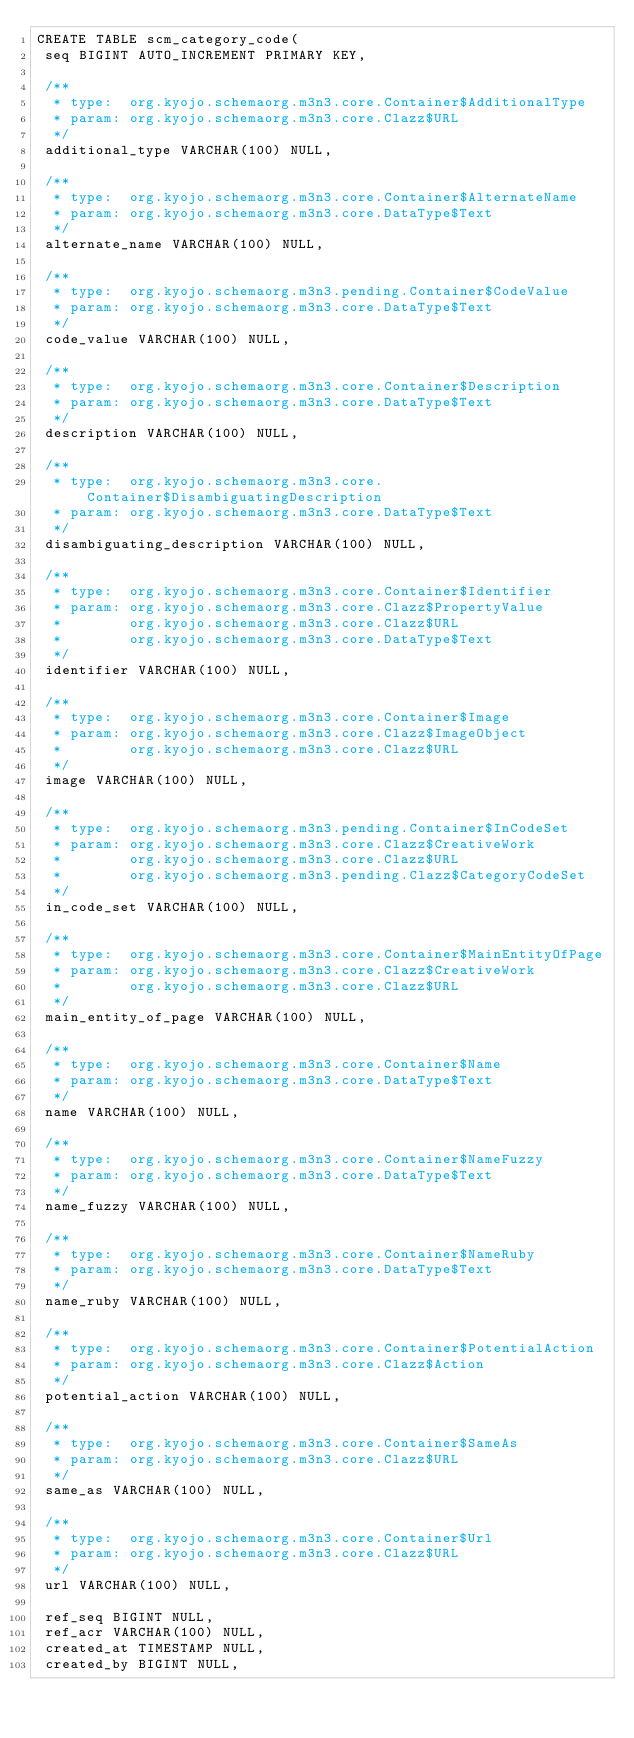<code> <loc_0><loc_0><loc_500><loc_500><_SQL_>CREATE TABLE scm_category_code(
 seq BIGINT AUTO_INCREMENT PRIMARY KEY,

 /**
  * type:  org.kyojo.schemaorg.m3n3.core.Container$AdditionalType
  * param: org.kyojo.schemaorg.m3n3.core.Clazz$URL
  */
 additional_type VARCHAR(100) NULL,

 /**
  * type:  org.kyojo.schemaorg.m3n3.core.Container$AlternateName
  * param: org.kyojo.schemaorg.m3n3.core.DataType$Text
  */
 alternate_name VARCHAR(100) NULL,

 /**
  * type:  org.kyojo.schemaorg.m3n3.pending.Container$CodeValue
  * param: org.kyojo.schemaorg.m3n3.core.DataType$Text
  */
 code_value VARCHAR(100) NULL,

 /**
  * type:  org.kyojo.schemaorg.m3n3.core.Container$Description
  * param: org.kyojo.schemaorg.m3n3.core.DataType$Text
  */
 description VARCHAR(100) NULL,

 /**
  * type:  org.kyojo.schemaorg.m3n3.core.Container$DisambiguatingDescription
  * param: org.kyojo.schemaorg.m3n3.core.DataType$Text
  */
 disambiguating_description VARCHAR(100) NULL,

 /**
  * type:  org.kyojo.schemaorg.m3n3.core.Container$Identifier
  * param: org.kyojo.schemaorg.m3n3.core.Clazz$PropertyValue
  *        org.kyojo.schemaorg.m3n3.core.Clazz$URL
  *        org.kyojo.schemaorg.m3n3.core.DataType$Text
  */
 identifier VARCHAR(100) NULL,

 /**
  * type:  org.kyojo.schemaorg.m3n3.core.Container$Image
  * param: org.kyojo.schemaorg.m3n3.core.Clazz$ImageObject
  *        org.kyojo.schemaorg.m3n3.core.Clazz$URL
  */
 image VARCHAR(100) NULL,

 /**
  * type:  org.kyojo.schemaorg.m3n3.pending.Container$InCodeSet
  * param: org.kyojo.schemaorg.m3n3.core.Clazz$CreativeWork
  *        org.kyojo.schemaorg.m3n3.core.Clazz$URL
  *        org.kyojo.schemaorg.m3n3.pending.Clazz$CategoryCodeSet
  */
 in_code_set VARCHAR(100) NULL,

 /**
  * type:  org.kyojo.schemaorg.m3n3.core.Container$MainEntityOfPage
  * param: org.kyojo.schemaorg.m3n3.core.Clazz$CreativeWork
  *        org.kyojo.schemaorg.m3n3.core.Clazz$URL
  */
 main_entity_of_page VARCHAR(100) NULL,

 /**
  * type:  org.kyojo.schemaorg.m3n3.core.Container$Name
  * param: org.kyojo.schemaorg.m3n3.core.DataType$Text
  */
 name VARCHAR(100) NULL,

 /**
  * type:  org.kyojo.schemaorg.m3n3.core.Container$NameFuzzy
  * param: org.kyojo.schemaorg.m3n3.core.DataType$Text
  */
 name_fuzzy VARCHAR(100) NULL,

 /**
  * type:  org.kyojo.schemaorg.m3n3.core.Container$NameRuby
  * param: org.kyojo.schemaorg.m3n3.core.DataType$Text
  */
 name_ruby VARCHAR(100) NULL,

 /**
  * type:  org.kyojo.schemaorg.m3n3.core.Container$PotentialAction
  * param: org.kyojo.schemaorg.m3n3.core.Clazz$Action
  */
 potential_action VARCHAR(100) NULL,

 /**
  * type:  org.kyojo.schemaorg.m3n3.core.Container$SameAs
  * param: org.kyojo.schemaorg.m3n3.core.Clazz$URL
  */
 same_as VARCHAR(100) NULL,

 /**
  * type:  org.kyojo.schemaorg.m3n3.core.Container$Url
  * param: org.kyojo.schemaorg.m3n3.core.Clazz$URL
  */
 url VARCHAR(100) NULL,

 ref_seq BIGINT NULL,
 ref_acr VARCHAR(100) NULL,
 created_at TIMESTAMP NULL,
 created_by BIGINT NULL,</code> 